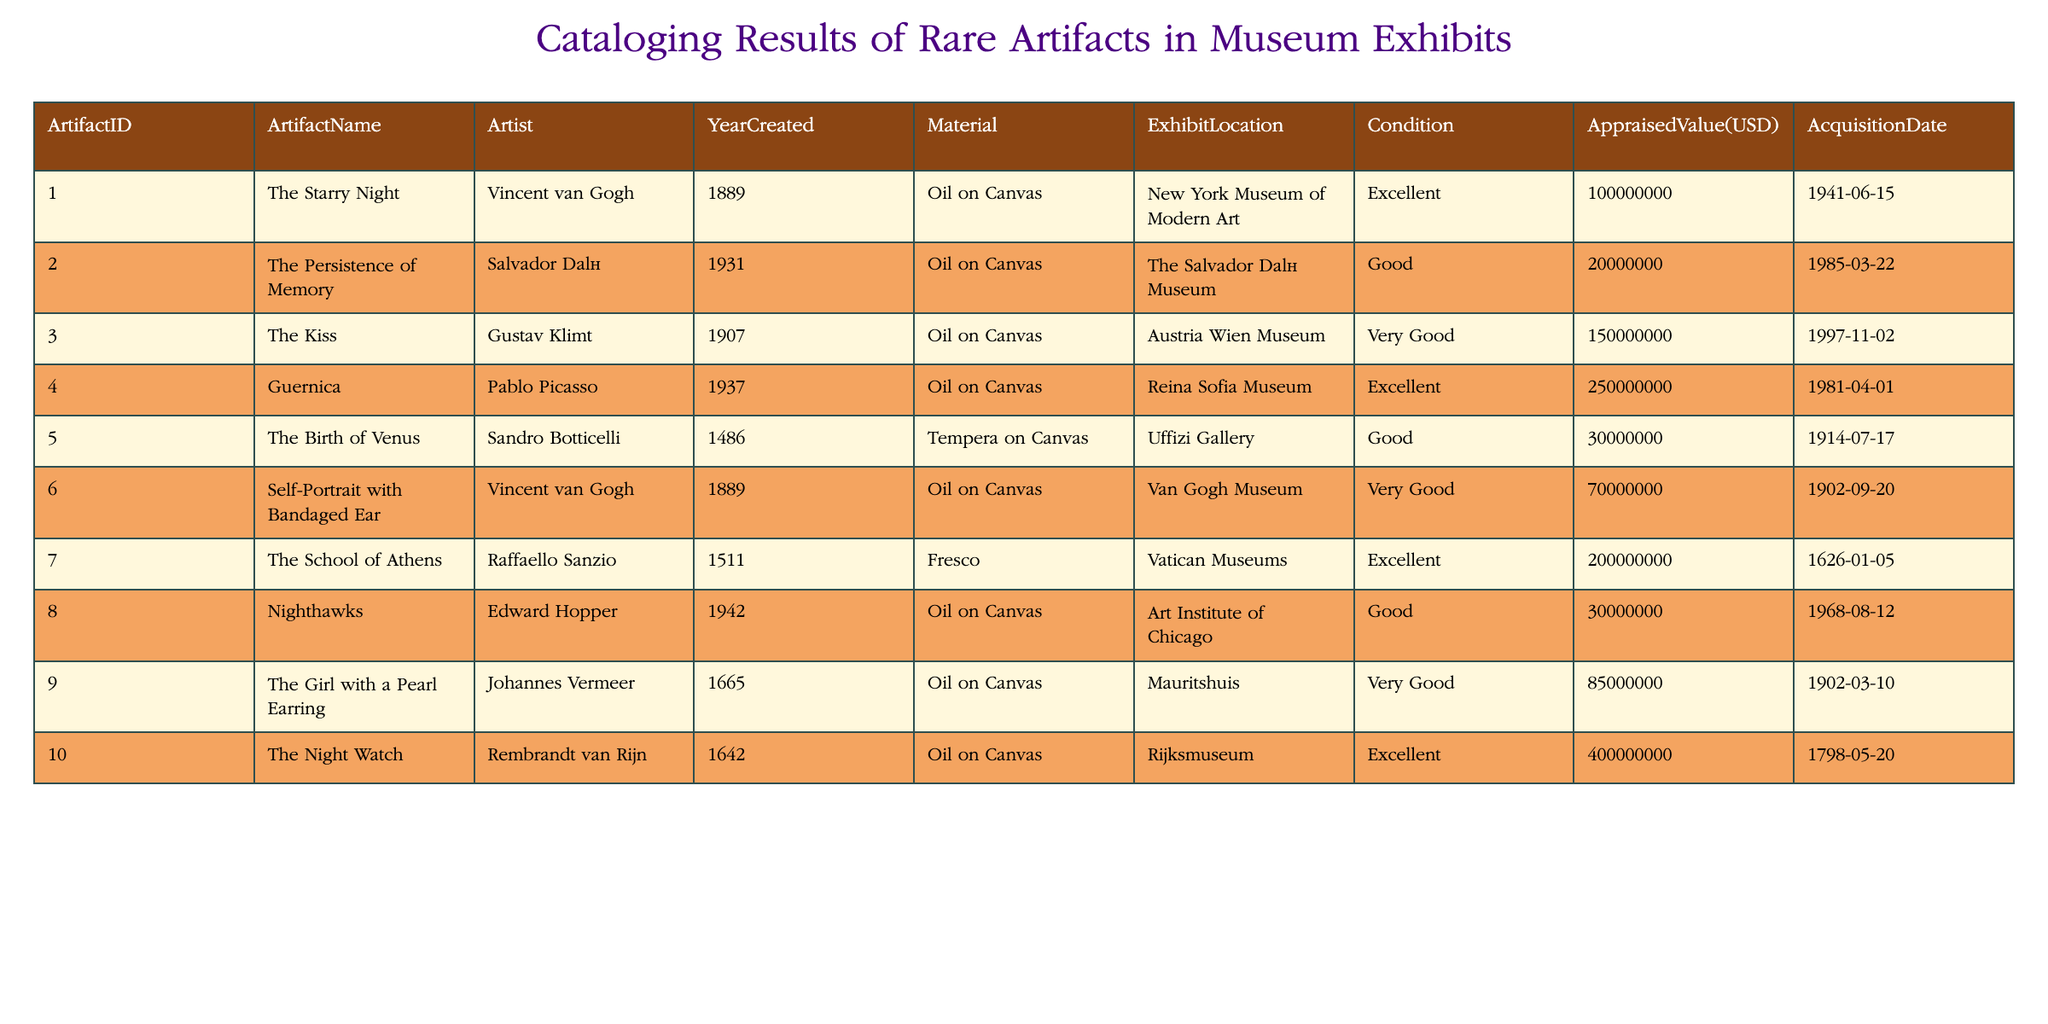What is the appraised value of The Kiss? The table shows that The Kiss has an appraised value listed under the Appraised Value column. Looking at the row for The Kiss, the value is 150000000 USD.
Answer: 150000000 Which artist created The Persistence of Memory? By examining the table, the Artist column for The Persistence of Memory indicates that it was created by Salvador Dalí.
Answer: Salvador Dalí How many artifacts have a condition labeled as Excellent? To determine this, I count the artifacts listed as Excellent in the Condition column. The artifacts are The Starry Night, Guernica, The School of Athens, and The Night Watch, totaling four artifacts.
Answer: 4 Is the appraised value of The Night Watch greater than 300 million USD? Checking the Appraised Value for The Night Watch, I find it listed as 400000000 USD. Since 400 million is indeed greater than 300 million, the answer is yes.
Answer: Yes What is the average appraised value of the artifacts in the table? First, I gather all the appraised values: 100000000, 20000000, 150000000, 250000000, 30000000, 70000000, 200000000, 30000000, 85000000, and 400000000, totaling 1,205,000,000. There are 10 artifacts, so the average is calculated as 1,205,000,000 divided by 10, equaling 120500000.
Answer: 120500000 Which artist has the highest appraised value artifact? I need to look through the Appraised Value column and identify which artist's work has the maximum value. The highest value is 400000000 for The Night Watch by Rembrandt van Rijn, making him the artist associated with the highest appraised value.
Answer: Rembrandt van Rijn Are there any artifacts created before the year 1500? Upon reviewing the Year Created column, I find that The Birth of Venus (1486) is the only artifact created before 1500. Therefore, the answer is yes, as there is at least one such artifact.
Answer: Yes Which exhibit location has the most artifacts listed? To identify this, I tally the occurrences of each Exhibit Location. New York Museum of Modern Art, The Salvador Dalí Museum, Austria Wien Museum, Reina Sofia Museum, Uffizi Gallery, Van Gogh Museum, Vatican Museums, Art Institute of Chicago, Mauritshuis, and Rijksmuseum are all listed once, indicating no location has more than one artifact.
Answer: None If an artifact is in Very Good condition, what is its average appraised value? I consider the artifacts with a condition of Very Good: The Kiss (150000000), Self-Portrait with Bandaged Ear (70000000), and The Girl with a Pearl Earring (85000000). Their values sum up to 305000000, and since there are three artifacts, I divide 305000000 by 3, yielding an average of 101666667.
Answer: 101666667 